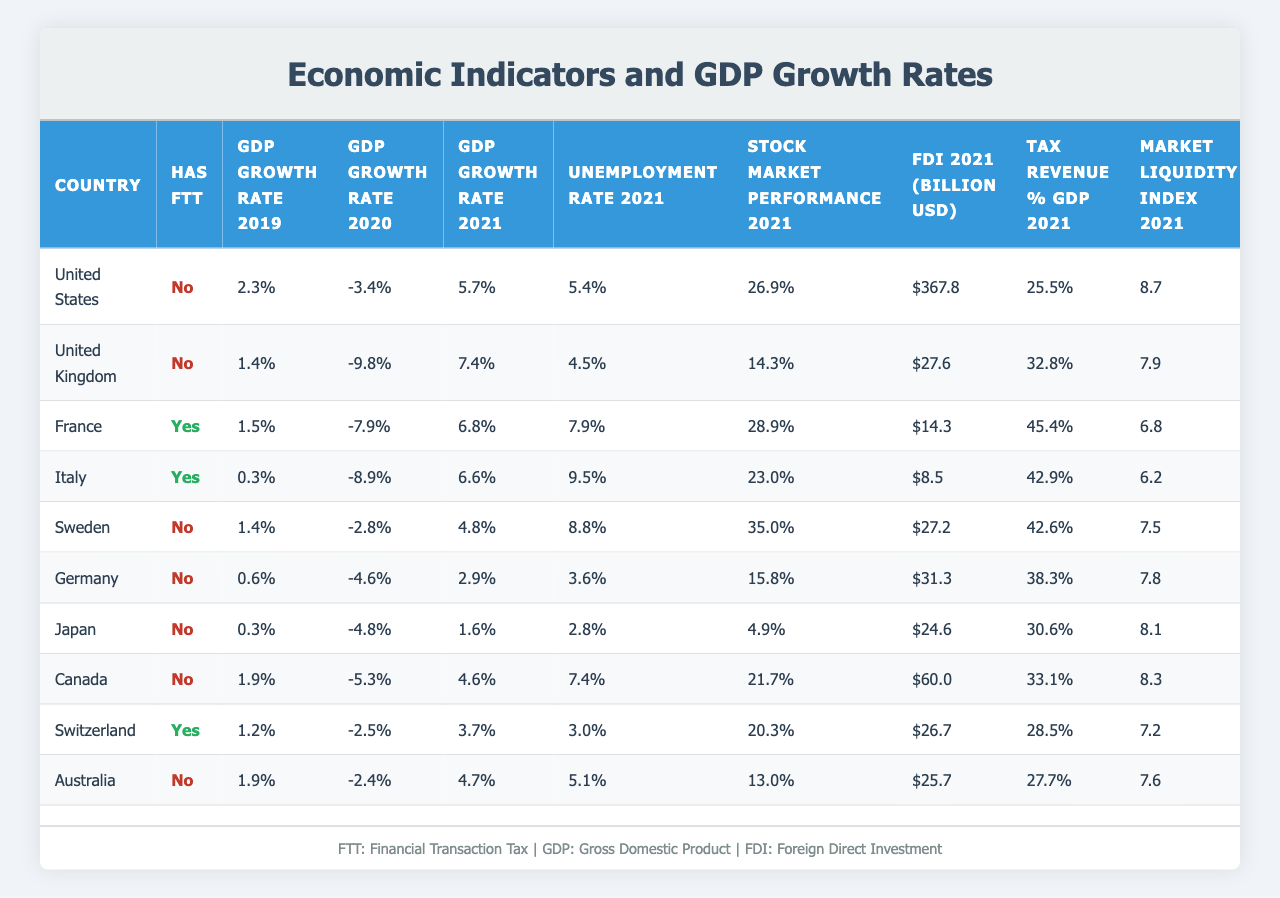What is the GDP growth rate of the United Kingdom in 2021? From the table, I can see that the GDP growth rate for the United Kingdom in 2021 is listed as 7.4%.
Answer: 7.4% Which country has the highest unemployment rate in 2021? The unemployment rates for 2021 are given for each country. By comparing these values, Italy has the highest unemployment rate at 9.5%.
Answer: Italy What is the difference in GDP growth rate from 2019 to 2021 for Germany? The GDP growth rates for Germany are 0.6% in 2019 and 2.9% in 2021. The difference is calculated as 2.9% - 0.6% = 2.3%.
Answer: 2.3% Does Sweden have a Financial Transaction Tax? In the table, it indicates that Sweden does not have a Financial Transaction Tax, showing "No" under the "Has FTT" column.
Answer: No What is the average GDP growth rate in 2020 for countries without a Financial Transaction Tax? The countries without FTT in 2020 are the United States, United Kingdom, Sweden, Germany, Canada, Australia, and the total for these countries is calculated as (-3.4 - 9.8 - 2.8 - 4.6 - 5.3 - 2.4) = -28.1%. There are 6 countries, so the average is -28.1% / 6 = -4.68%.
Answer: -4.68% What is the country with the lowest Stock Market Performance in 2021? By reviewing the Stock Market Performance values, Japan with 4.9% shows the lowest performance compared to the other countries.
Answer: Japan What is the relationship between having a Financial Transaction Tax and the GDP growth rate in 2021? To evaluate this, I compare countries with and without the FTT. Countries with FTT (France and Italy) had growth rates of 6.8% and 6.6%, respectively. Countries without FTT averaged 4.56% (based on their growth rates), indicating that countries without FTT generally had lower growth rates.
Answer: Countries without FTT had generally lower growth rates What is the total Foreign Direct Investment in billion USD for the countries with a Financial Transaction Tax? The FTT countries are France (14.3), Italy (8.5), and Switzerland (26.7). Adding these values gives a total of 14.3 + 8.5 + 26.7 = 49.5 billion USD.
Answer: 49.5 billion USD For which country is the Market Liquidity Index in 2021 the highest? The table shows that Sweden has the highest Market Liquidity Index at 7.5 compared to all other countries listed.
Answer: Sweden What was the GDP growth rate in 2020 for France? According to the table, the GDP growth rate for France in 2020 is -7.9%.
Answer: -7.9% 